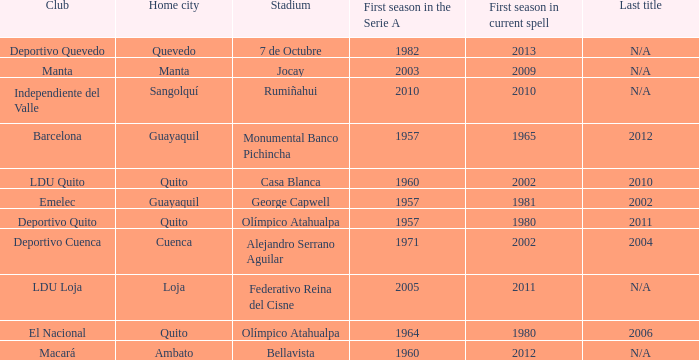Name the last title for 2012 N/A. 